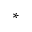<formula> <loc_0><loc_0><loc_500><loc_500>^ { * }</formula> 